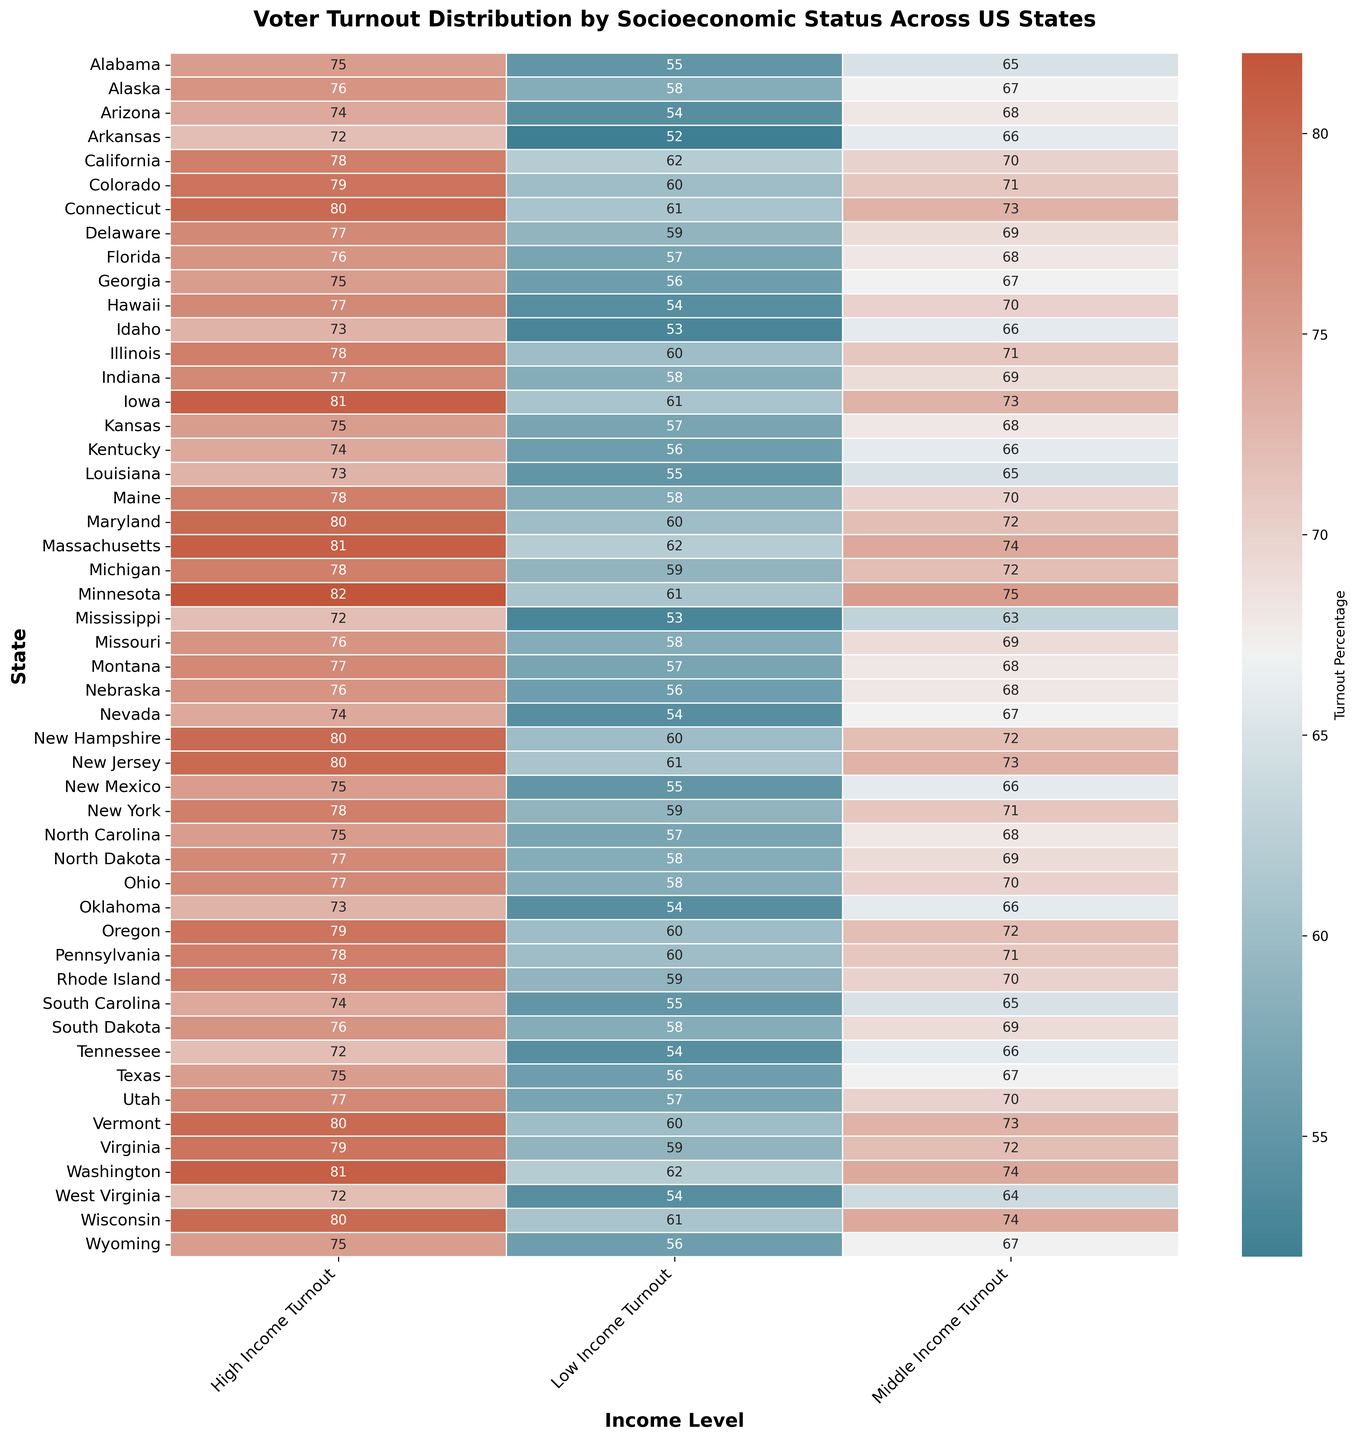What's the highest voter turnout for high-income individuals across all states? Identify the column for "High Income Turnout" and locate the highest value in that column. The highest value is 82, which appears in Minnesota.
Answer: 82 Which state has the lowest voter turnout for low-income individuals? Locate the "Low Income Turnout" column and find the smallest number. The smallest number is 52, which is for Arkansas.
Answer: Arkansas How does the voter turnout for low-income individuals in California compare with that of Texas? Check the "Low Income Turnout" values for California and Texas. California has 62, while Texas has 56. 62 is greater than 56.
Answer: California is higher What's the average voter turnout for middle-income individuals in the states starting with 'N'? Calculate the average for the middle-income turnouts of Nebraska (68), Nevada (67), New Hampshire (72), New Jersey (73), New Mexico (66), New York (71), North Carolina (68), and North Dakota (69). The sum is 554, and there are 8 states, so the average is 554 / 8 = 69.25.
Answer: 69.25 Which state has the smallest difference between high-income and low-income voter turnout? Calculate the differences for each state and find the smallest one. For example, Alabama has a difference of 75 - 55 = 20, Alaska has 76 - 58 = 18, etc. The smallest difference is 18, found in Alaska.
Answer: Alaska Are there more states with high-income voter turnout above 80 or low-income voter turnout below 55? Count the states in the "High Income Turnout" column with values above 80 (3 states: Iowa, Massachusetts, Minnesota) and the states in the "Low Income Turnout" column with values below 55 (3 states: Arkansas, Mississippi, Tennessee). Both counts are equal.
Answer: Equal What’s the sum of the middle-income voter turnout for the states in the Pacific Time Zone (California, Oregon, Washington)? Add the middle-income turnout values of California (70), Oregon (72), and Washington (74). The total is 70 + 72 + 74 = 216.
Answer: 216 Which state has the highest middle-income voter turnout? Locate the "Middle Income Turnout" column and find the highest value. The highest value is 75, which is for Minnesota.
Answer: Minnesota What is the range of voter turnout for low-income individuals across all states? Identify the highest (62 in California) and lowest (52 in Arkansas) values in the "Low Income Turnout" column. The range is 62 - 52 = 10.
Answer: 10 Is the voter turnout for high-income individuals in Massachusetts higher than the average high-income voter turnout across all states? Calculate the average high-income voter turnout: sum all values in the "High Income Turnout" column (3585) and divide by 51 (number of states): 3585 / 51 ≈ 70.29. Compare with Massachusetts’s high-income turnout of 81, which is higher.
Answer: Yes 